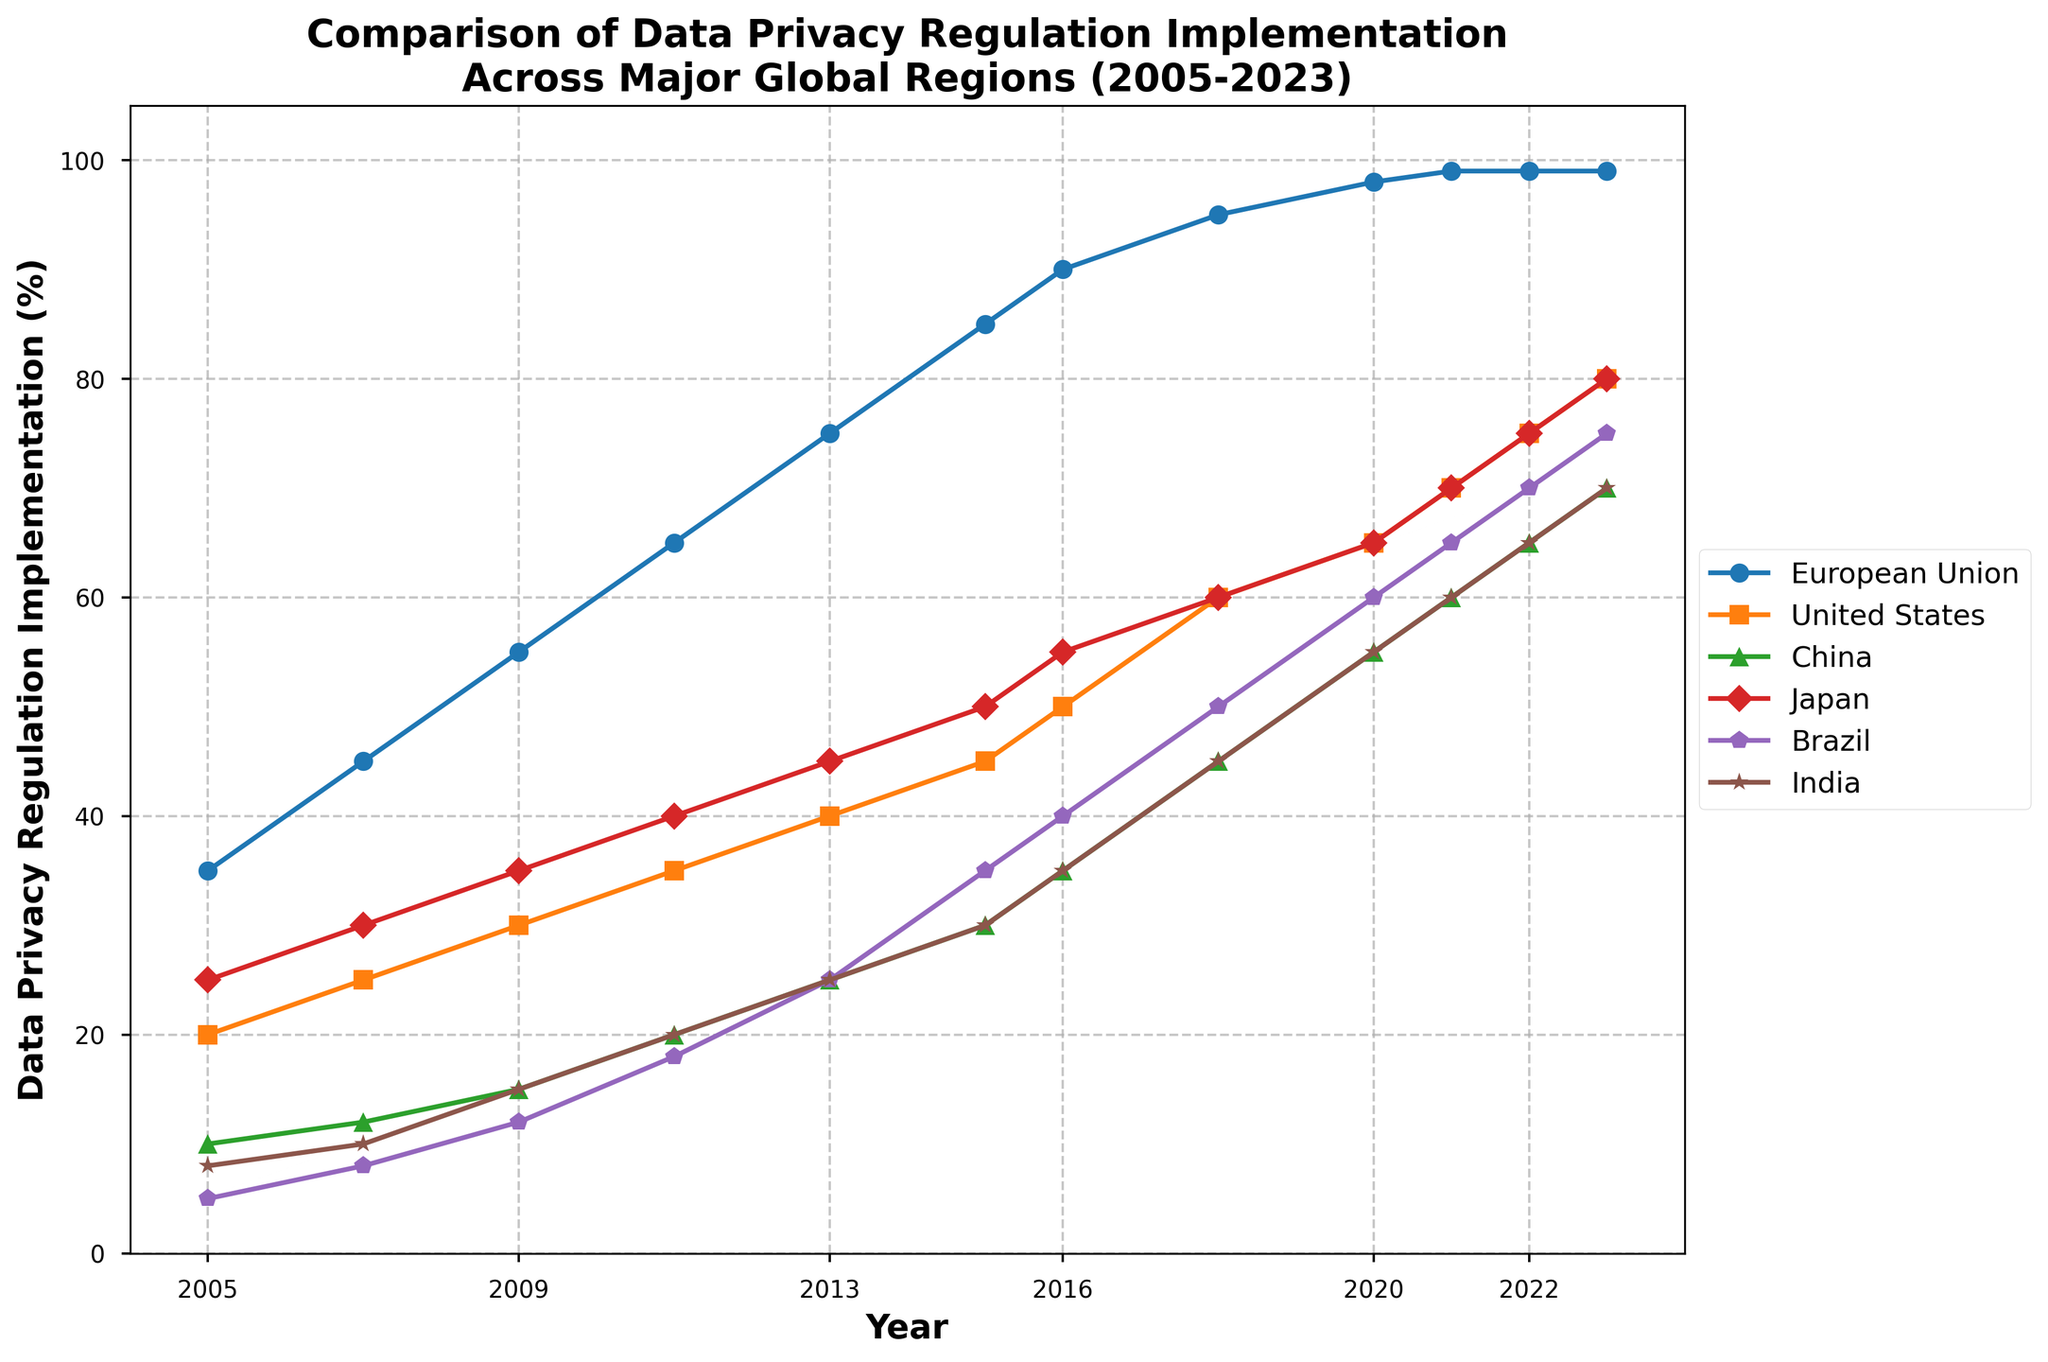What year did the European Union reach 90% in data privacy regulation implementation? Look for the year on the x-axis where the European Union's line intersects the 90% mark on the y-axis. In this case, it is between 2015 and 2018, exactly at 2016.
Answer: 2016 Which region had the highest percentage of data privacy regulation implementation in 2023? Look for the highest point along the y-axis for the year 2023 among all regions. The European Union's line reaches 99% in 2023.
Answer: European Union Between China and Japan, which region had a faster growth rate in data privacy regulation implementation between 2005 and 2023? Compare the slopes of the lines representing China and Japan from 2005 to 2023. Calculate the overall change for both regions: China increased from 10% to 70%, and Japan from 25% to 80%. China had a larger increase (60%) over Japan's (55%).
Answer: China By how much did Brazil's data privacy regulation implementation increase from 2005 to 2023? Find Brazil's data points on the y-axis for both 2005 and 2023. Subtract the 2005 value (5%) from the 2023 value (75%).
Answer: 70% Which region showed consistent growth, without any decline, in their data privacy regulation implementation from 2005 to 2023? Look for a line that continuously rises without any dips from 2005 to 2023. The European Union's line consistently increases without any drops.
Answer: European Union What was the combined data privacy regulation implementation for Brazil and India in 2020? Find the 2020 values for both Brazil (60%) and India (55%). Add them together: 60% + 55%.
Answer: 115% Which region had the smallest increase in data privacy regulation implementation between 2005 and 2023? Calculate the difference in implementation from 2005 to 2023 for each region. United States increased from 20% to 80%, Europe from 35% to 99%, China from 10% to 70%, Japan from 25% to 80%, Brazil from 5% to 75%, and India from 8% to 70%. India had the smallest increase (62%).
Answer: India How many years did it take for the United States to reach 50% data privacy regulation implementation? Determine when the United States first reaches 50%. It goes from 20% in 2005 to 50% in 2016. Therefore, subtract 2005 from 2016.
Answer: 11 years Which region's line is represented by a red color? Identify the line plot that is visually marked in red. The line for China is represented in red color.
Answer: China What year did India have the same data privacy regulation implementation percentage as China did in 2015? Find the value for China in 2015, which is 30%. Look for the year on India's line that matches 30%, which is 2015.
Answer: 2015 